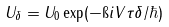<formula> <loc_0><loc_0><loc_500><loc_500>U _ { \delta } = U _ { 0 } \exp ( - \i i V \tau \delta / \hbar { ) }</formula> 